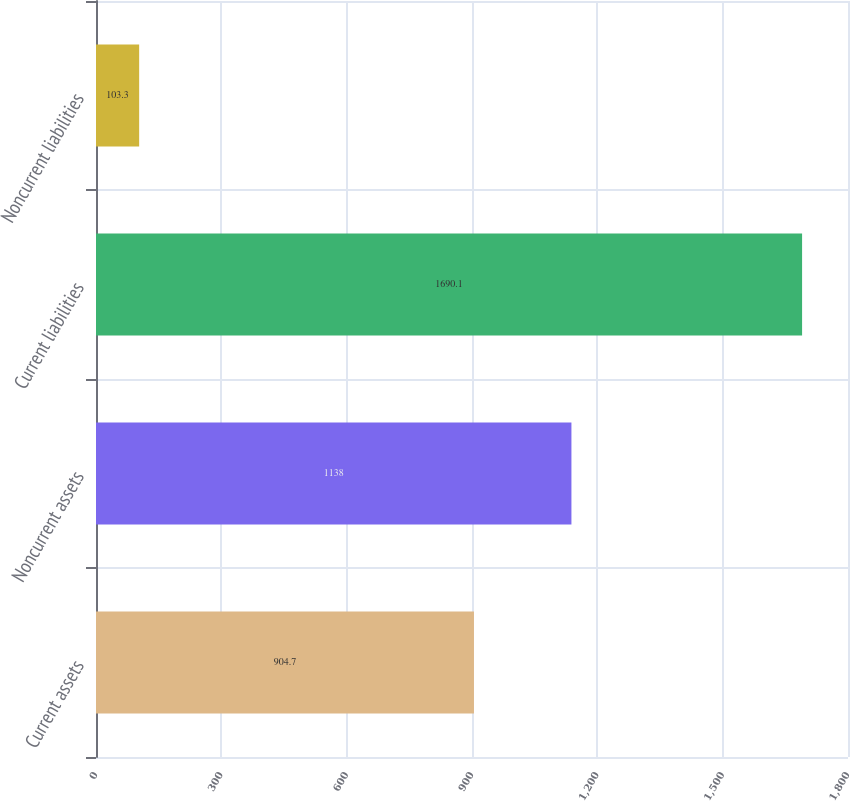Convert chart. <chart><loc_0><loc_0><loc_500><loc_500><bar_chart><fcel>Current assets<fcel>Noncurrent assets<fcel>Current liabilities<fcel>Noncurrent liabilities<nl><fcel>904.7<fcel>1138<fcel>1690.1<fcel>103.3<nl></chart> 